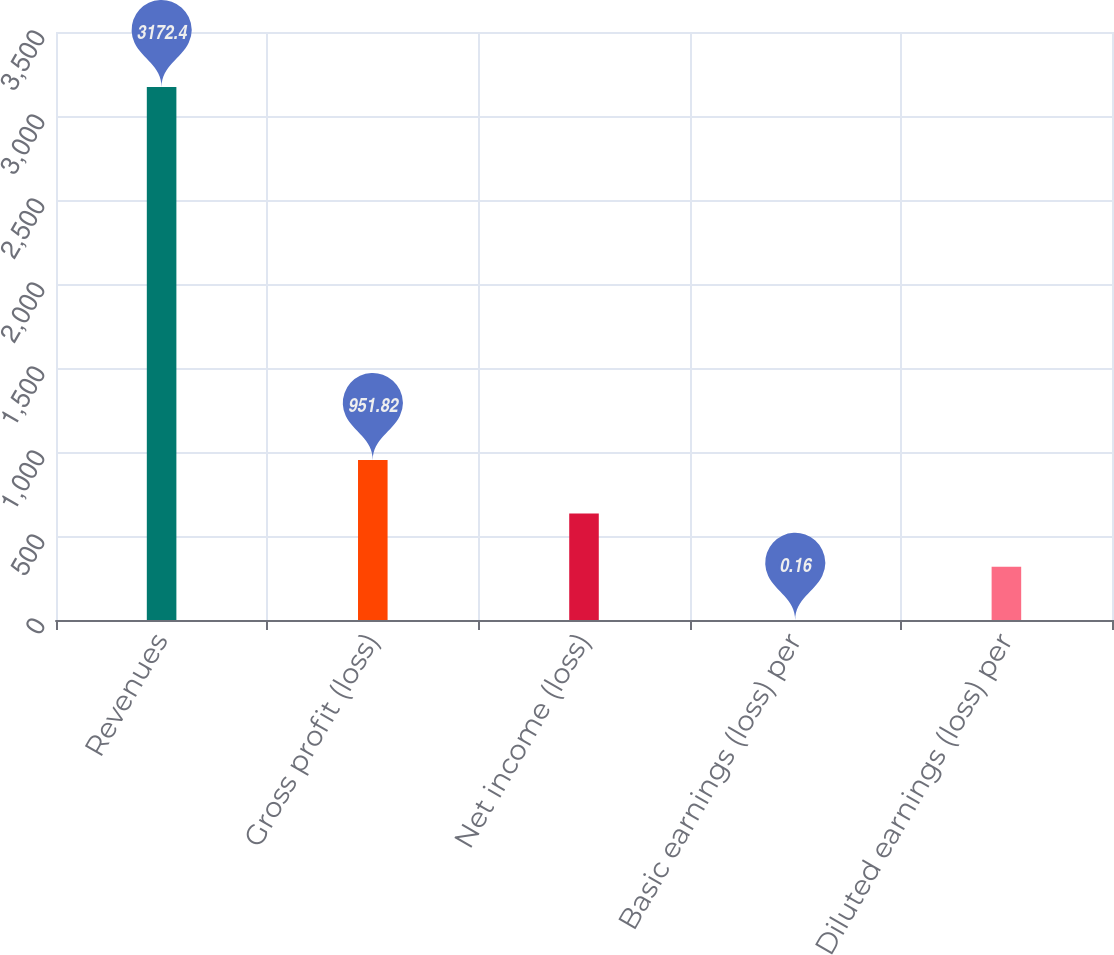Convert chart to OTSL. <chart><loc_0><loc_0><loc_500><loc_500><bar_chart><fcel>Revenues<fcel>Gross profit (loss)<fcel>Net income (loss)<fcel>Basic earnings (loss) per<fcel>Diluted earnings (loss) per<nl><fcel>3172.4<fcel>951.82<fcel>634.6<fcel>0.16<fcel>317.38<nl></chart> 